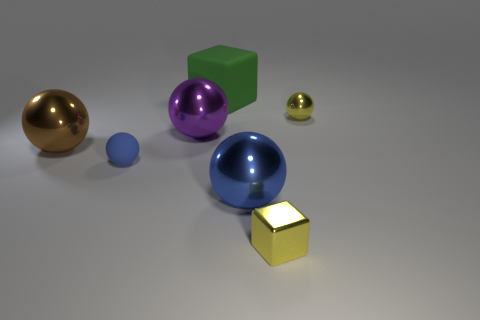Subtract all large purple balls. How many balls are left? 4 Add 3 tiny shiny blocks. How many objects exist? 10 Subtract all yellow balls. How many balls are left? 4 Add 5 small shiny spheres. How many small shiny spheres exist? 6 Subtract 0 cyan cylinders. How many objects are left? 7 Subtract all spheres. How many objects are left? 2 Subtract 2 blocks. How many blocks are left? 0 Subtract all red balls. Subtract all red cylinders. How many balls are left? 5 Subtract all blue blocks. How many brown spheres are left? 1 Subtract all blue shiny spheres. Subtract all brown metal balls. How many objects are left? 5 